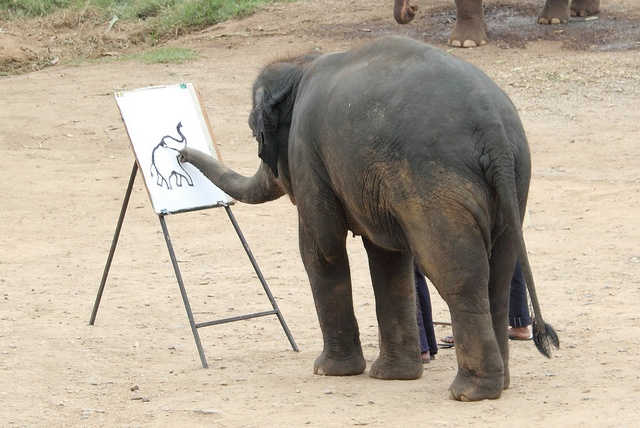Describe the objects in this image and their specific colors. I can see elephant in olive, gray, black, and darkgray tones, elephant in olive, gray, maroon, and tan tones, people in olive, black, and gray tones, and people in olive, black, and gray tones in this image. 